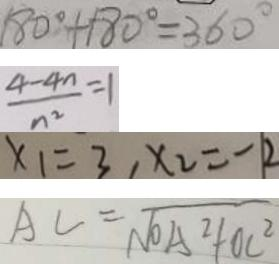Convert formula to latex. <formula><loc_0><loc_0><loc_500><loc_500>1 8 0 ^ { \circ } + 1 8 0 ^ { \circ } = 3 6 0 ^ { \circ } 
 \frac { 4 - 4 n } { n ^ { 2 } } = 1 
 x _ { 1 } = 3 , x _ { 2 } = - 2 
 A C = \sqrt { O A ^ { 2 } + O C ^ { 2 } }</formula> 